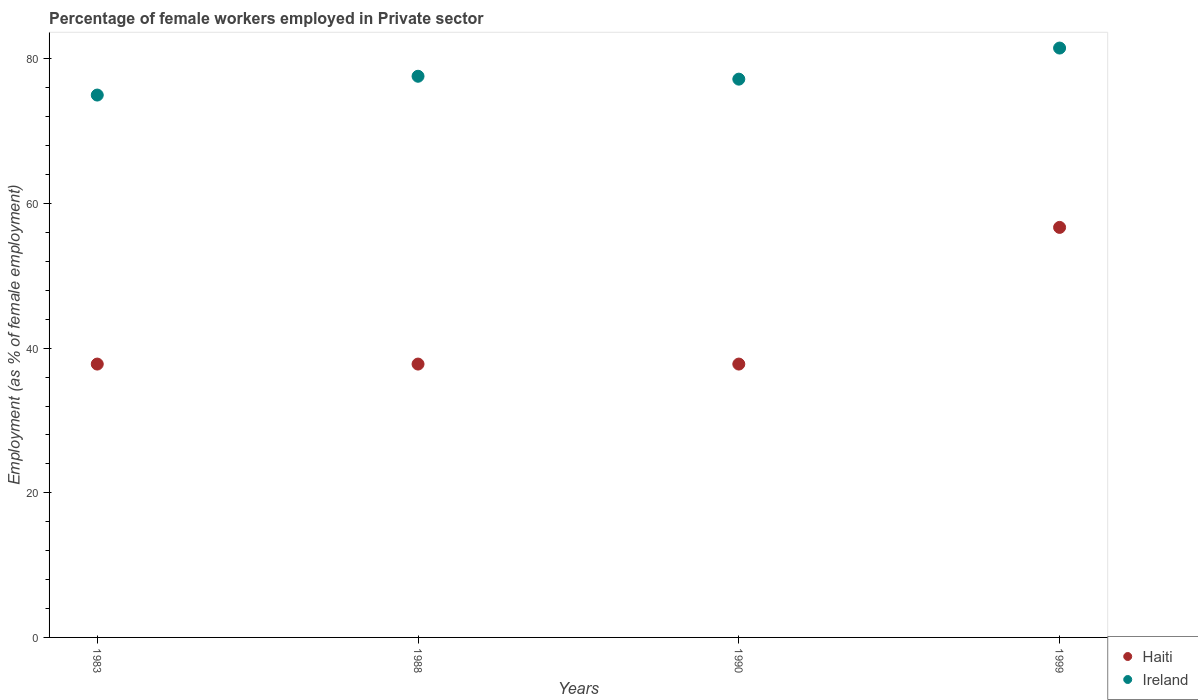How many different coloured dotlines are there?
Keep it short and to the point. 2. What is the percentage of females employed in Private sector in Haiti in 1983?
Offer a terse response. 37.8. Across all years, what is the maximum percentage of females employed in Private sector in Haiti?
Your answer should be compact. 56.7. Across all years, what is the minimum percentage of females employed in Private sector in Haiti?
Provide a succinct answer. 37.8. What is the total percentage of females employed in Private sector in Haiti in the graph?
Your answer should be very brief. 170.1. What is the difference between the percentage of females employed in Private sector in Haiti in 1988 and that in 1999?
Ensure brevity in your answer.  -18.9. What is the difference between the percentage of females employed in Private sector in Ireland in 1988 and the percentage of females employed in Private sector in Haiti in 1983?
Offer a very short reply. 39.8. What is the average percentage of females employed in Private sector in Haiti per year?
Offer a terse response. 42.52. In the year 1990, what is the difference between the percentage of females employed in Private sector in Ireland and percentage of females employed in Private sector in Haiti?
Ensure brevity in your answer.  39.4. In how many years, is the percentage of females employed in Private sector in Haiti greater than 48 %?
Ensure brevity in your answer.  1. Is the percentage of females employed in Private sector in Ireland in 1983 less than that in 1999?
Ensure brevity in your answer.  Yes. What is the difference between the highest and the second highest percentage of females employed in Private sector in Ireland?
Make the answer very short. 3.9. What is the difference between the highest and the lowest percentage of females employed in Private sector in Ireland?
Your answer should be compact. 6.5. In how many years, is the percentage of females employed in Private sector in Ireland greater than the average percentage of females employed in Private sector in Ireland taken over all years?
Provide a short and direct response. 1. Is the sum of the percentage of females employed in Private sector in Haiti in 1988 and 1990 greater than the maximum percentage of females employed in Private sector in Ireland across all years?
Your response must be concise. No. Does the percentage of females employed in Private sector in Haiti monotonically increase over the years?
Offer a very short reply. No. How many dotlines are there?
Offer a terse response. 2. How many years are there in the graph?
Provide a succinct answer. 4. What is the difference between two consecutive major ticks on the Y-axis?
Provide a succinct answer. 20. Are the values on the major ticks of Y-axis written in scientific E-notation?
Give a very brief answer. No. Does the graph contain grids?
Your response must be concise. No. Where does the legend appear in the graph?
Offer a terse response. Bottom right. What is the title of the graph?
Your response must be concise. Percentage of female workers employed in Private sector. What is the label or title of the X-axis?
Keep it short and to the point. Years. What is the label or title of the Y-axis?
Provide a succinct answer. Employment (as % of female employment). What is the Employment (as % of female employment) in Haiti in 1983?
Give a very brief answer. 37.8. What is the Employment (as % of female employment) in Haiti in 1988?
Keep it short and to the point. 37.8. What is the Employment (as % of female employment) of Ireland in 1988?
Make the answer very short. 77.6. What is the Employment (as % of female employment) of Haiti in 1990?
Your answer should be compact. 37.8. What is the Employment (as % of female employment) of Ireland in 1990?
Your answer should be very brief. 77.2. What is the Employment (as % of female employment) in Haiti in 1999?
Offer a very short reply. 56.7. What is the Employment (as % of female employment) in Ireland in 1999?
Your answer should be compact. 81.5. Across all years, what is the maximum Employment (as % of female employment) of Haiti?
Your answer should be compact. 56.7. Across all years, what is the maximum Employment (as % of female employment) in Ireland?
Provide a short and direct response. 81.5. Across all years, what is the minimum Employment (as % of female employment) of Haiti?
Give a very brief answer. 37.8. What is the total Employment (as % of female employment) in Haiti in the graph?
Offer a very short reply. 170.1. What is the total Employment (as % of female employment) of Ireland in the graph?
Provide a succinct answer. 311.3. What is the difference between the Employment (as % of female employment) of Haiti in 1983 and that in 1988?
Offer a very short reply. 0. What is the difference between the Employment (as % of female employment) of Ireland in 1983 and that in 1990?
Offer a terse response. -2.2. What is the difference between the Employment (as % of female employment) in Haiti in 1983 and that in 1999?
Your answer should be very brief. -18.9. What is the difference between the Employment (as % of female employment) in Haiti in 1988 and that in 1999?
Provide a short and direct response. -18.9. What is the difference between the Employment (as % of female employment) in Haiti in 1990 and that in 1999?
Your answer should be compact. -18.9. What is the difference between the Employment (as % of female employment) in Ireland in 1990 and that in 1999?
Keep it short and to the point. -4.3. What is the difference between the Employment (as % of female employment) of Haiti in 1983 and the Employment (as % of female employment) of Ireland in 1988?
Offer a terse response. -39.8. What is the difference between the Employment (as % of female employment) of Haiti in 1983 and the Employment (as % of female employment) of Ireland in 1990?
Your answer should be very brief. -39.4. What is the difference between the Employment (as % of female employment) of Haiti in 1983 and the Employment (as % of female employment) of Ireland in 1999?
Your response must be concise. -43.7. What is the difference between the Employment (as % of female employment) of Haiti in 1988 and the Employment (as % of female employment) of Ireland in 1990?
Keep it short and to the point. -39.4. What is the difference between the Employment (as % of female employment) in Haiti in 1988 and the Employment (as % of female employment) in Ireland in 1999?
Ensure brevity in your answer.  -43.7. What is the difference between the Employment (as % of female employment) of Haiti in 1990 and the Employment (as % of female employment) of Ireland in 1999?
Your response must be concise. -43.7. What is the average Employment (as % of female employment) in Haiti per year?
Keep it short and to the point. 42.52. What is the average Employment (as % of female employment) of Ireland per year?
Your answer should be compact. 77.83. In the year 1983, what is the difference between the Employment (as % of female employment) of Haiti and Employment (as % of female employment) of Ireland?
Your answer should be compact. -37.2. In the year 1988, what is the difference between the Employment (as % of female employment) of Haiti and Employment (as % of female employment) of Ireland?
Provide a short and direct response. -39.8. In the year 1990, what is the difference between the Employment (as % of female employment) in Haiti and Employment (as % of female employment) in Ireland?
Keep it short and to the point. -39.4. In the year 1999, what is the difference between the Employment (as % of female employment) of Haiti and Employment (as % of female employment) of Ireland?
Ensure brevity in your answer.  -24.8. What is the ratio of the Employment (as % of female employment) in Ireland in 1983 to that in 1988?
Your answer should be compact. 0.97. What is the ratio of the Employment (as % of female employment) in Ireland in 1983 to that in 1990?
Ensure brevity in your answer.  0.97. What is the ratio of the Employment (as % of female employment) of Ireland in 1983 to that in 1999?
Give a very brief answer. 0.92. What is the ratio of the Employment (as % of female employment) in Ireland in 1988 to that in 1990?
Your answer should be very brief. 1.01. What is the ratio of the Employment (as % of female employment) of Haiti in 1988 to that in 1999?
Your answer should be compact. 0.67. What is the ratio of the Employment (as % of female employment) in Ireland in 1988 to that in 1999?
Offer a terse response. 0.95. What is the ratio of the Employment (as % of female employment) in Haiti in 1990 to that in 1999?
Ensure brevity in your answer.  0.67. What is the ratio of the Employment (as % of female employment) in Ireland in 1990 to that in 1999?
Your answer should be compact. 0.95. What is the difference between the highest and the lowest Employment (as % of female employment) of Haiti?
Give a very brief answer. 18.9. What is the difference between the highest and the lowest Employment (as % of female employment) of Ireland?
Provide a succinct answer. 6.5. 